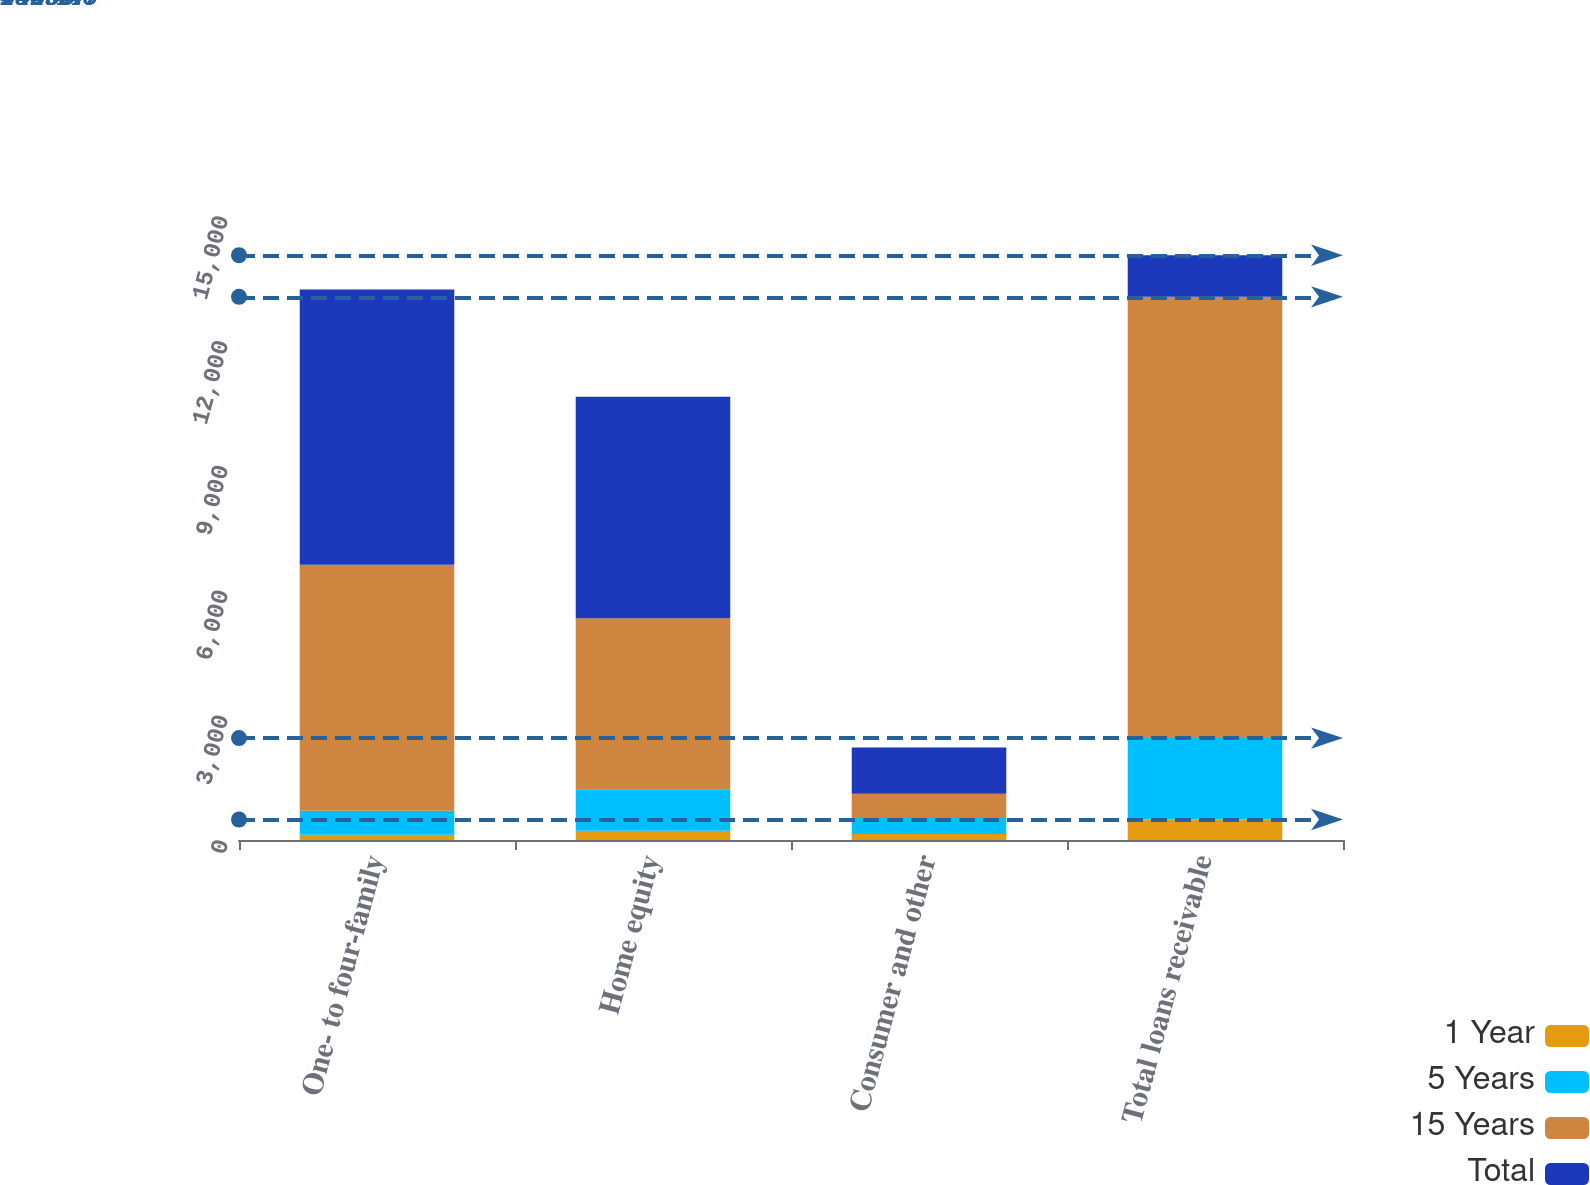Convert chart. <chart><loc_0><loc_0><loc_500><loc_500><stacked_bar_chart><ecel><fcel>One- to four-family<fcel>Home equity<fcel>Consumer and other<fcel>Total loans receivable<nl><fcel>1 Year<fcel>127.1<fcel>220.9<fcel>144.4<fcel>492.4<nl><fcel>5 Years<fcel>573.9<fcel>998.9<fcel>384.2<fcel>1957<nl><fcel>15 Years<fcel>5914.8<fcel>4108.9<fcel>584.6<fcel>10608.3<nl><fcel>Total<fcel>6615.8<fcel>5328.7<fcel>1113.2<fcel>998.9<nl></chart> 